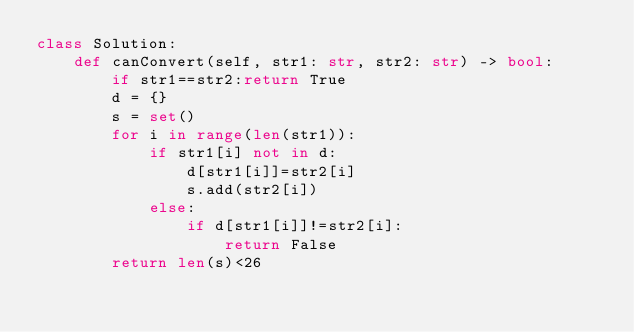<code> <loc_0><loc_0><loc_500><loc_500><_Python_>class Solution:
    def canConvert(self, str1: str, str2: str) -> bool:
        if str1==str2:return True
        d = {}
        s = set()
        for i in range(len(str1)):
            if str1[i] not in d:
                d[str1[i]]=str2[i]
                s.add(str2[i])
            else:
                if d[str1[i]]!=str2[i]:
                    return False
        return len(s)<26</code> 